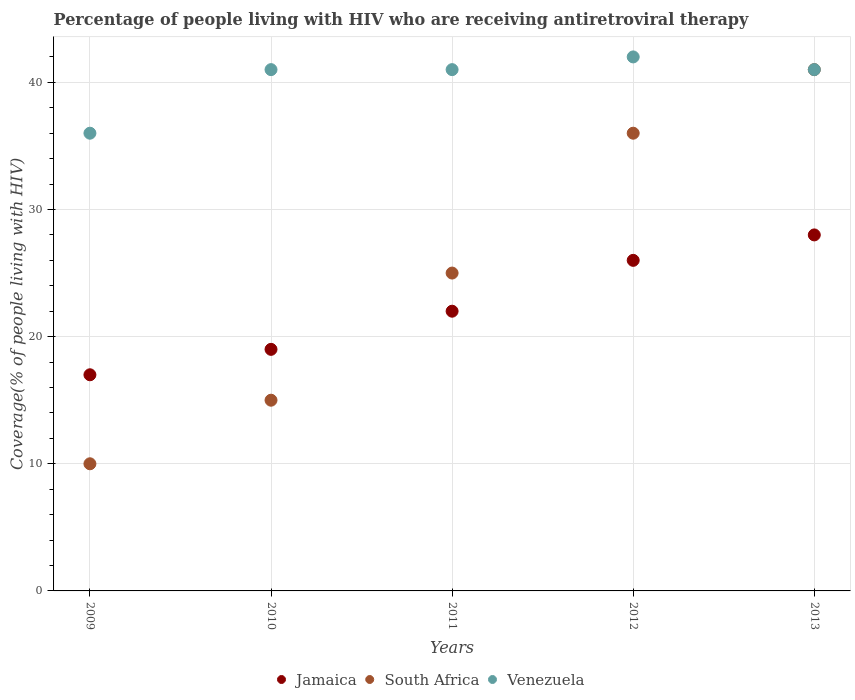How many different coloured dotlines are there?
Offer a very short reply. 3. What is the percentage of the HIV infected people who are receiving antiretroviral therapy in Venezuela in 2009?
Provide a succinct answer. 36. Across all years, what is the maximum percentage of the HIV infected people who are receiving antiretroviral therapy in Jamaica?
Make the answer very short. 28. Across all years, what is the minimum percentage of the HIV infected people who are receiving antiretroviral therapy in Jamaica?
Your answer should be compact. 17. What is the total percentage of the HIV infected people who are receiving antiretroviral therapy in Jamaica in the graph?
Your answer should be compact. 112. What is the difference between the percentage of the HIV infected people who are receiving antiretroviral therapy in South Africa in 2009 and that in 2010?
Offer a terse response. -5. What is the difference between the percentage of the HIV infected people who are receiving antiretroviral therapy in Venezuela in 2012 and the percentage of the HIV infected people who are receiving antiretroviral therapy in South Africa in 2010?
Provide a succinct answer. 27. What is the average percentage of the HIV infected people who are receiving antiretroviral therapy in Jamaica per year?
Offer a terse response. 22.4. In how many years, is the percentage of the HIV infected people who are receiving antiretroviral therapy in Venezuela greater than 12 %?
Provide a succinct answer. 5. What is the ratio of the percentage of the HIV infected people who are receiving antiretroviral therapy in Jamaica in 2010 to that in 2013?
Provide a succinct answer. 0.68. Is the percentage of the HIV infected people who are receiving antiretroviral therapy in South Africa in 2010 less than that in 2012?
Make the answer very short. Yes. Is the difference between the percentage of the HIV infected people who are receiving antiretroviral therapy in South Africa in 2009 and 2013 greater than the difference between the percentage of the HIV infected people who are receiving antiretroviral therapy in Venezuela in 2009 and 2013?
Offer a very short reply. No. In how many years, is the percentage of the HIV infected people who are receiving antiretroviral therapy in South Africa greater than the average percentage of the HIV infected people who are receiving antiretroviral therapy in South Africa taken over all years?
Provide a succinct answer. 2. Is it the case that in every year, the sum of the percentage of the HIV infected people who are receiving antiretroviral therapy in Jamaica and percentage of the HIV infected people who are receiving antiretroviral therapy in Venezuela  is greater than the percentage of the HIV infected people who are receiving antiretroviral therapy in South Africa?
Make the answer very short. Yes. Does the percentage of the HIV infected people who are receiving antiretroviral therapy in Jamaica monotonically increase over the years?
Your answer should be very brief. Yes. Is the percentage of the HIV infected people who are receiving antiretroviral therapy in South Africa strictly less than the percentage of the HIV infected people who are receiving antiretroviral therapy in Jamaica over the years?
Your answer should be very brief. No. How many years are there in the graph?
Keep it short and to the point. 5. What is the difference between two consecutive major ticks on the Y-axis?
Your answer should be compact. 10. Does the graph contain grids?
Your answer should be compact. Yes. Where does the legend appear in the graph?
Your response must be concise. Bottom center. How many legend labels are there?
Your answer should be very brief. 3. What is the title of the graph?
Offer a very short reply. Percentage of people living with HIV who are receiving antiretroviral therapy. What is the label or title of the X-axis?
Provide a short and direct response. Years. What is the label or title of the Y-axis?
Your answer should be compact. Coverage(% of people living with HIV). What is the Coverage(% of people living with HIV) of Venezuela in 2010?
Provide a short and direct response. 41. What is the Coverage(% of people living with HIV) in Jamaica in 2012?
Make the answer very short. 26. What is the Coverage(% of people living with HIV) in Jamaica in 2013?
Your answer should be compact. 28. What is the Coverage(% of people living with HIV) in Venezuela in 2013?
Provide a succinct answer. 41. Across all years, what is the maximum Coverage(% of people living with HIV) of Jamaica?
Provide a short and direct response. 28. Across all years, what is the maximum Coverage(% of people living with HIV) in South Africa?
Provide a succinct answer. 41. Across all years, what is the maximum Coverage(% of people living with HIV) in Venezuela?
Your response must be concise. 42. What is the total Coverage(% of people living with HIV) of Jamaica in the graph?
Make the answer very short. 112. What is the total Coverage(% of people living with HIV) in South Africa in the graph?
Provide a short and direct response. 127. What is the total Coverage(% of people living with HIV) in Venezuela in the graph?
Offer a terse response. 201. What is the difference between the Coverage(% of people living with HIV) in Jamaica in 2009 and that in 2010?
Provide a short and direct response. -2. What is the difference between the Coverage(% of people living with HIV) of South Africa in 2009 and that in 2010?
Your answer should be compact. -5. What is the difference between the Coverage(% of people living with HIV) in Venezuela in 2009 and that in 2010?
Offer a terse response. -5. What is the difference between the Coverage(% of people living with HIV) in Jamaica in 2009 and that in 2011?
Ensure brevity in your answer.  -5. What is the difference between the Coverage(% of people living with HIV) in Venezuela in 2009 and that in 2011?
Offer a terse response. -5. What is the difference between the Coverage(% of people living with HIV) of Jamaica in 2009 and that in 2012?
Your response must be concise. -9. What is the difference between the Coverage(% of people living with HIV) of South Africa in 2009 and that in 2012?
Provide a succinct answer. -26. What is the difference between the Coverage(% of people living with HIV) in Venezuela in 2009 and that in 2012?
Provide a succinct answer. -6. What is the difference between the Coverage(% of people living with HIV) in Jamaica in 2009 and that in 2013?
Offer a very short reply. -11. What is the difference between the Coverage(% of people living with HIV) of South Africa in 2009 and that in 2013?
Your answer should be very brief. -31. What is the difference between the Coverage(% of people living with HIV) of Venezuela in 2009 and that in 2013?
Keep it short and to the point. -5. What is the difference between the Coverage(% of people living with HIV) of Jamaica in 2010 and that in 2011?
Provide a succinct answer. -3. What is the difference between the Coverage(% of people living with HIV) of South Africa in 2010 and that in 2013?
Make the answer very short. -26. What is the difference between the Coverage(% of people living with HIV) in Venezuela in 2010 and that in 2013?
Your answer should be compact. 0. What is the difference between the Coverage(% of people living with HIV) of South Africa in 2011 and that in 2012?
Offer a very short reply. -11. What is the difference between the Coverage(% of people living with HIV) in Venezuela in 2011 and that in 2012?
Offer a very short reply. -1. What is the difference between the Coverage(% of people living with HIV) in South Africa in 2011 and that in 2013?
Keep it short and to the point. -16. What is the difference between the Coverage(% of people living with HIV) in Jamaica in 2012 and that in 2013?
Offer a terse response. -2. What is the difference between the Coverage(% of people living with HIV) in Venezuela in 2012 and that in 2013?
Your answer should be very brief. 1. What is the difference between the Coverage(% of people living with HIV) of Jamaica in 2009 and the Coverage(% of people living with HIV) of South Africa in 2010?
Ensure brevity in your answer.  2. What is the difference between the Coverage(% of people living with HIV) of South Africa in 2009 and the Coverage(% of people living with HIV) of Venezuela in 2010?
Your answer should be compact. -31. What is the difference between the Coverage(% of people living with HIV) in South Africa in 2009 and the Coverage(% of people living with HIV) in Venezuela in 2011?
Your answer should be very brief. -31. What is the difference between the Coverage(% of people living with HIV) of Jamaica in 2009 and the Coverage(% of people living with HIV) of South Africa in 2012?
Offer a terse response. -19. What is the difference between the Coverage(% of people living with HIV) of Jamaica in 2009 and the Coverage(% of people living with HIV) of Venezuela in 2012?
Your answer should be compact. -25. What is the difference between the Coverage(% of people living with HIV) of South Africa in 2009 and the Coverage(% of people living with HIV) of Venezuela in 2012?
Offer a very short reply. -32. What is the difference between the Coverage(% of people living with HIV) of South Africa in 2009 and the Coverage(% of people living with HIV) of Venezuela in 2013?
Provide a short and direct response. -31. What is the difference between the Coverage(% of people living with HIV) in Jamaica in 2010 and the Coverage(% of people living with HIV) in South Africa in 2011?
Your response must be concise. -6. What is the difference between the Coverage(% of people living with HIV) in Jamaica in 2010 and the Coverage(% of people living with HIV) in Venezuela in 2011?
Ensure brevity in your answer.  -22. What is the difference between the Coverage(% of people living with HIV) in South Africa in 2010 and the Coverage(% of people living with HIV) in Venezuela in 2011?
Keep it short and to the point. -26. What is the difference between the Coverage(% of people living with HIV) in South Africa in 2010 and the Coverage(% of people living with HIV) in Venezuela in 2012?
Offer a very short reply. -27. What is the difference between the Coverage(% of people living with HIV) of South Africa in 2010 and the Coverage(% of people living with HIV) of Venezuela in 2013?
Your answer should be compact. -26. What is the difference between the Coverage(% of people living with HIV) of Jamaica in 2011 and the Coverage(% of people living with HIV) of Venezuela in 2012?
Ensure brevity in your answer.  -20. What is the difference between the Coverage(% of people living with HIV) in South Africa in 2011 and the Coverage(% of people living with HIV) in Venezuela in 2012?
Give a very brief answer. -17. What is the difference between the Coverage(% of people living with HIV) of Jamaica in 2011 and the Coverage(% of people living with HIV) of South Africa in 2013?
Your response must be concise. -19. What is the difference between the Coverage(% of people living with HIV) of Jamaica in 2011 and the Coverage(% of people living with HIV) of Venezuela in 2013?
Provide a short and direct response. -19. What is the difference between the Coverage(% of people living with HIV) of South Africa in 2011 and the Coverage(% of people living with HIV) of Venezuela in 2013?
Keep it short and to the point. -16. What is the average Coverage(% of people living with HIV) in Jamaica per year?
Provide a succinct answer. 22.4. What is the average Coverage(% of people living with HIV) in South Africa per year?
Your response must be concise. 25.4. What is the average Coverage(% of people living with HIV) of Venezuela per year?
Your answer should be compact. 40.2. In the year 2009, what is the difference between the Coverage(% of people living with HIV) of Jamaica and Coverage(% of people living with HIV) of South Africa?
Keep it short and to the point. 7. In the year 2009, what is the difference between the Coverage(% of people living with HIV) of South Africa and Coverage(% of people living with HIV) of Venezuela?
Make the answer very short. -26. In the year 2010, what is the difference between the Coverage(% of people living with HIV) of Jamaica and Coverage(% of people living with HIV) of South Africa?
Your answer should be very brief. 4. In the year 2010, what is the difference between the Coverage(% of people living with HIV) in Jamaica and Coverage(% of people living with HIV) in Venezuela?
Give a very brief answer. -22. In the year 2010, what is the difference between the Coverage(% of people living with HIV) in South Africa and Coverage(% of people living with HIV) in Venezuela?
Keep it short and to the point. -26. In the year 2011, what is the difference between the Coverage(% of people living with HIV) in Jamaica and Coverage(% of people living with HIV) in South Africa?
Provide a short and direct response. -3. In the year 2011, what is the difference between the Coverage(% of people living with HIV) of South Africa and Coverage(% of people living with HIV) of Venezuela?
Offer a very short reply. -16. In the year 2012, what is the difference between the Coverage(% of people living with HIV) of South Africa and Coverage(% of people living with HIV) of Venezuela?
Give a very brief answer. -6. In the year 2013, what is the difference between the Coverage(% of people living with HIV) of Jamaica and Coverage(% of people living with HIV) of Venezuela?
Provide a succinct answer. -13. In the year 2013, what is the difference between the Coverage(% of people living with HIV) in South Africa and Coverage(% of people living with HIV) in Venezuela?
Offer a very short reply. 0. What is the ratio of the Coverage(% of people living with HIV) in Jamaica in 2009 to that in 2010?
Your response must be concise. 0.89. What is the ratio of the Coverage(% of people living with HIV) in Venezuela in 2009 to that in 2010?
Provide a short and direct response. 0.88. What is the ratio of the Coverage(% of people living with HIV) in Jamaica in 2009 to that in 2011?
Provide a succinct answer. 0.77. What is the ratio of the Coverage(% of people living with HIV) in South Africa in 2009 to that in 2011?
Provide a short and direct response. 0.4. What is the ratio of the Coverage(% of people living with HIV) in Venezuela in 2009 to that in 2011?
Your answer should be compact. 0.88. What is the ratio of the Coverage(% of people living with HIV) in Jamaica in 2009 to that in 2012?
Offer a very short reply. 0.65. What is the ratio of the Coverage(% of people living with HIV) of South Africa in 2009 to that in 2012?
Make the answer very short. 0.28. What is the ratio of the Coverage(% of people living with HIV) in Jamaica in 2009 to that in 2013?
Make the answer very short. 0.61. What is the ratio of the Coverage(% of people living with HIV) of South Africa in 2009 to that in 2013?
Make the answer very short. 0.24. What is the ratio of the Coverage(% of people living with HIV) in Venezuela in 2009 to that in 2013?
Your response must be concise. 0.88. What is the ratio of the Coverage(% of people living with HIV) in Jamaica in 2010 to that in 2011?
Ensure brevity in your answer.  0.86. What is the ratio of the Coverage(% of people living with HIV) in South Africa in 2010 to that in 2011?
Offer a terse response. 0.6. What is the ratio of the Coverage(% of people living with HIV) of Jamaica in 2010 to that in 2012?
Offer a terse response. 0.73. What is the ratio of the Coverage(% of people living with HIV) of South Africa in 2010 to that in 2012?
Make the answer very short. 0.42. What is the ratio of the Coverage(% of people living with HIV) in Venezuela in 2010 to that in 2012?
Ensure brevity in your answer.  0.98. What is the ratio of the Coverage(% of people living with HIV) of Jamaica in 2010 to that in 2013?
Offer a very short reply. 0.68. What is the ratio of the Coverage(% of people living with HIV) in South Africa in 2010 to that in 2013?
Give a very brief answer. 0.37. What is the ratio of the Coverage(% of people living with HIV) of Jamaica in 2011 to that in 2012?
Your answer should be very brief. 0.85. What is the ratio of the Coverage(% of people living with HIV) of South Africa in 2011 to that in 2012?
Offer a very short reply. 0.69. What is the ratio of the Coverage(% of people living with HIV) in Venezuela in 2011 to that in 2012?
Provide a short and direct response. 0.98. What is the ratio of the Coverage(% of people living with HIV) of Jamaica in 2011 to that in 2013?
Provide a succinct answer. 0.79. What is the ratio of the Coverage(% of people living with HIV) in South Africa in 2011 to that in 2013?
Give a very brief answer. 0.61. What is the ratio of the Coverage(% of people living with HIV) of Venezuela in 2011 to that in 2013?
Your response must be concise. 1. What is the ratio of the Coverage(% of people living with HIV) of South Africa in 2012 to that in 2013?
Your answer should be compact. 0.88. What is the ratio of the Coverage(% of people living with HIV) of Venezuela in 2012 to that in 2013?
Keep it short and to the point. 1.02. What is the difference between the highest and the lowest Coverage(% of people living with HIV) of South Africa?
Provide a short and direct response. 31. What is the difference between the highest and the lowest Coverage(% of people living with HIV) of Venezuela?
Provide a succinct answer. 6. 